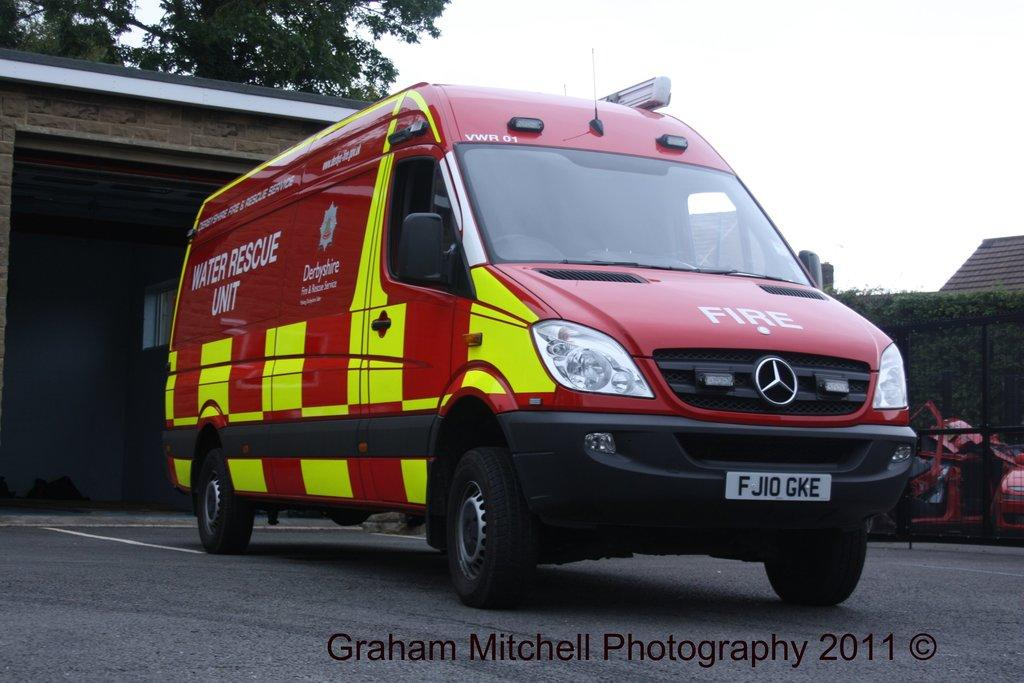<image>
Present a compact description of the photo's key features. A  red water rescue unit truck on pavement. 